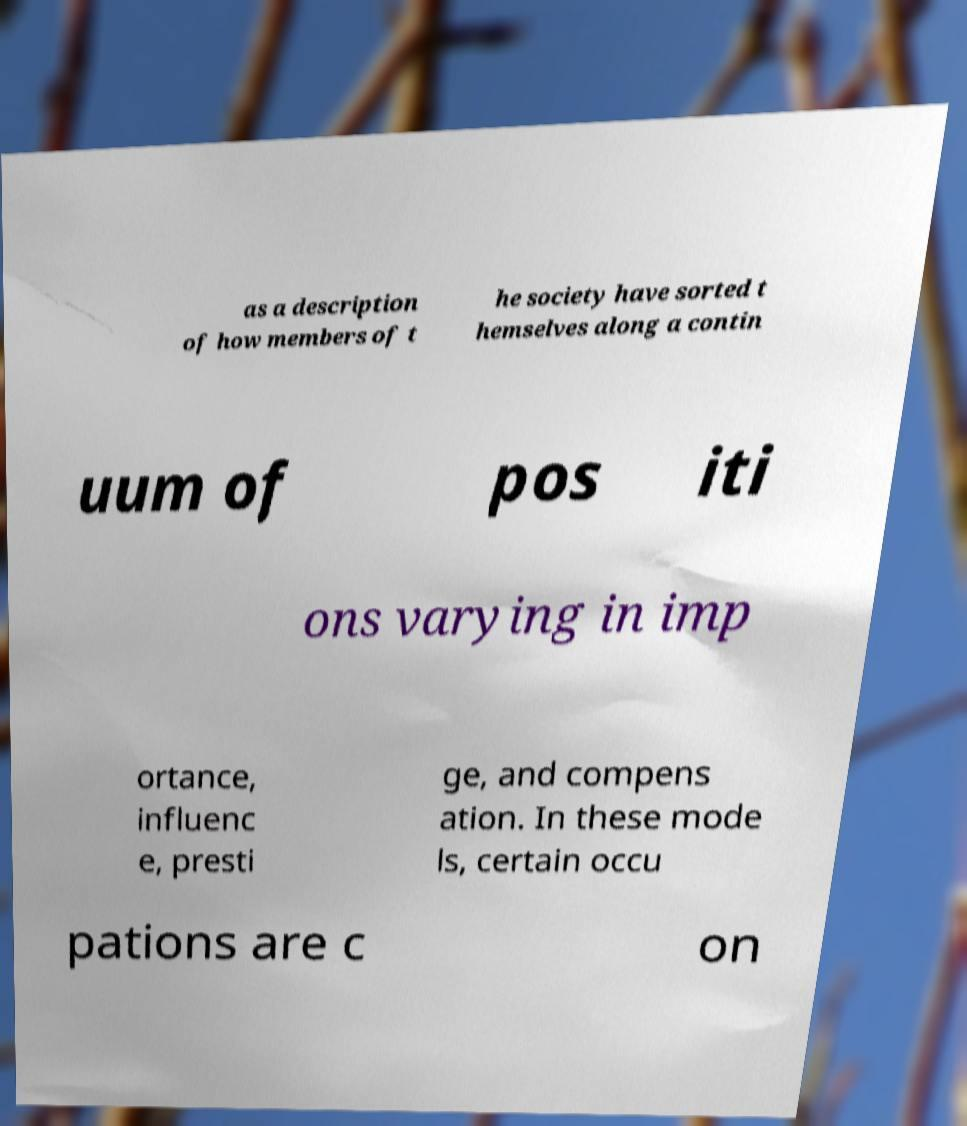Could you assist in decoding the text presented in this image and type it out clearly? as a description of how members of t he society have sorted t hemselves along a contin uum of pos iti ons varying in imp ortance, influenc e, presti ge, and compens ation. In these mode ls, certain occu pations are c on 